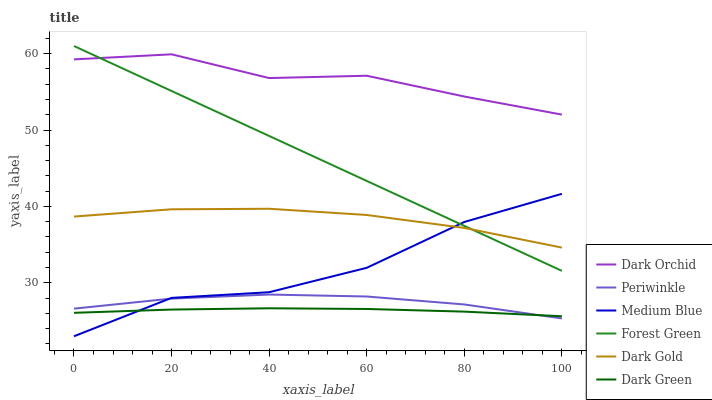Does Medium Blue have the minimum area under the curve?
Answer yes or no. No. Does Medium Blue have the maximum area under the curve?
Answer yes or no. No. Is Dark Orchid the smoothest?
Answer yes or no. No. Is Dark Orchid the roughest?
Answer yes or no. No. Does Dark Orchid have the lowest value?
Answer yes or no. No. Does Medium Blue have the highest value?
Answer yes or no. No. Is Periwinkle less than Dark Orchid?
Answer yes or no. Yes. Is Dark Gold greater than Dark Green?
Answer yes or no. Yes. Does Periwinkle intersect Dark Orchid?
Answer yes or no. No. 